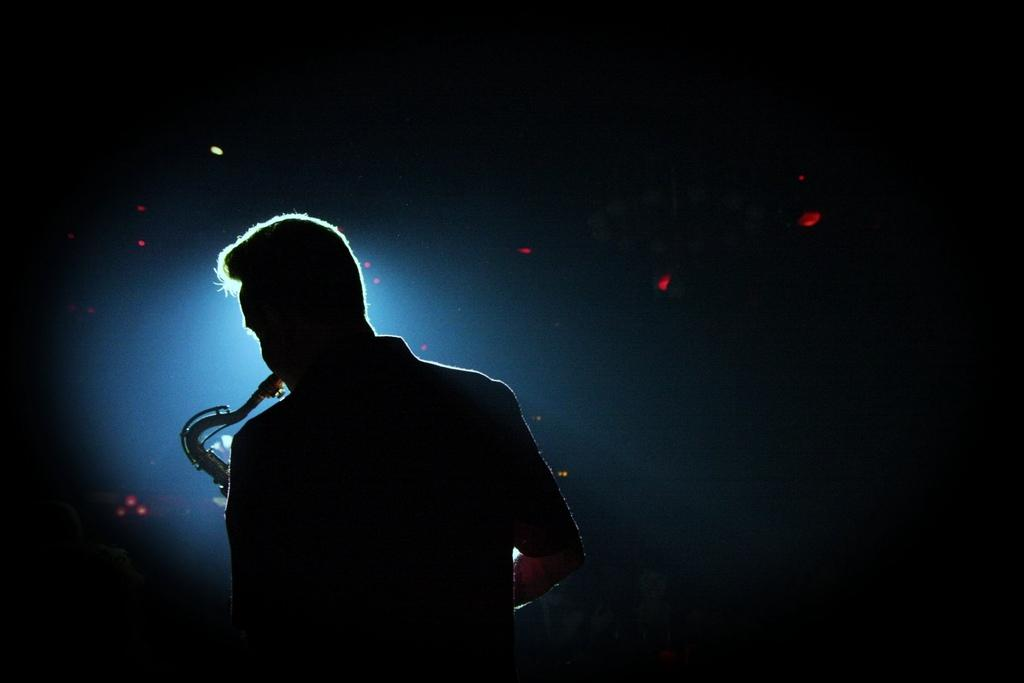What is the main subject of the image? There is a person in the image. What is the person doing in the image? The person is playing a musical instrument. Can you describe the background of the image? The background of the image has black, red, and blue colors. How many receipts can be seen in the image? There are no receipts present in the image. What type of crowd is visible in the image? There is no crowd visible in the image; it features a single person playing a musical instrument. 